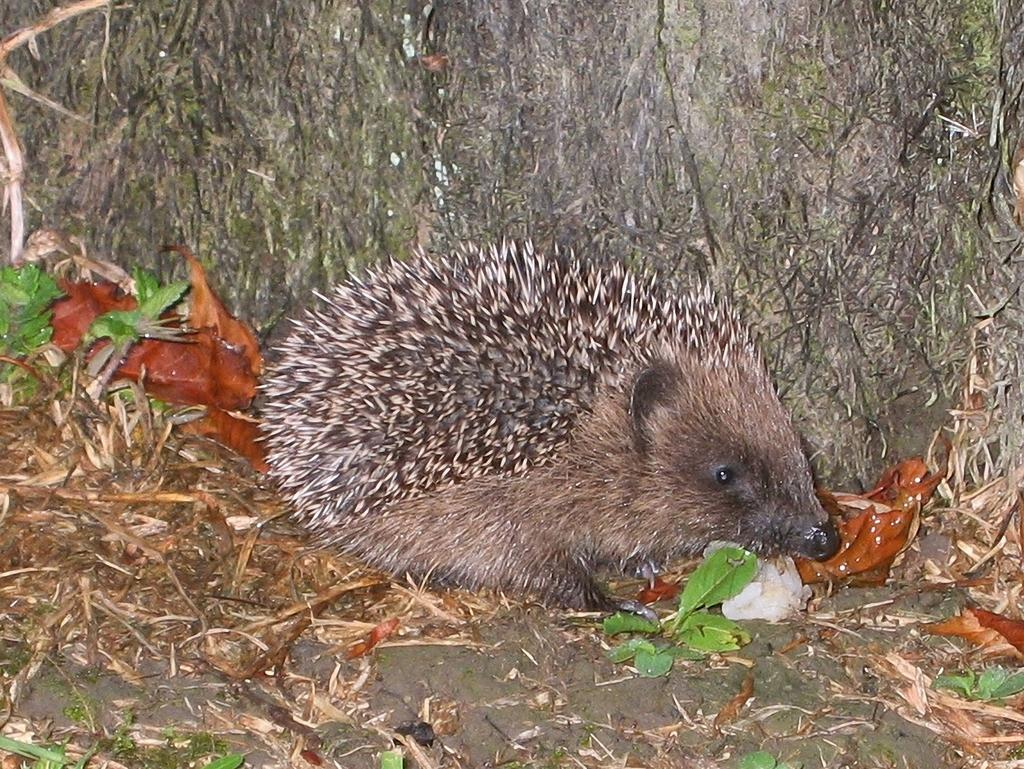What type of animal is in the image? There is an animal in the image, but the specific type cannot be determined from the provided facts. What natural elements are present in the image? There are leaves and sticks on the ground visible in the image. What can be seen in the background of the image? There is a tree trunk visible in the background of the image. What type of cactus is growing in the image? There is no cactus present in the image; it features an animal, leaves, sticks on the ground, and a tree trunk in the background. 